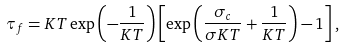Convert formula to latex. <formula><loc_0><loc_0><loc_500><loc_500>\tau _ { f } = K T \exp \left ( - \frac { 1 } { K T } \right ) \left [ \exp \left ( \frac { \sigma _ { c } } { \sigma K T } + \frac { 1 } { K T } \right ) - 1 \right ] ,</formula> 